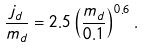<formula> <loc_0><loc_0><loc_500><loc_500>\frac { j _ { d } } { m _ { d } } = 2 . 5 \left ( \frac { m _ { d } } { 0 . 1 } \right ) ^ { 0 . 6 } .</formula> 